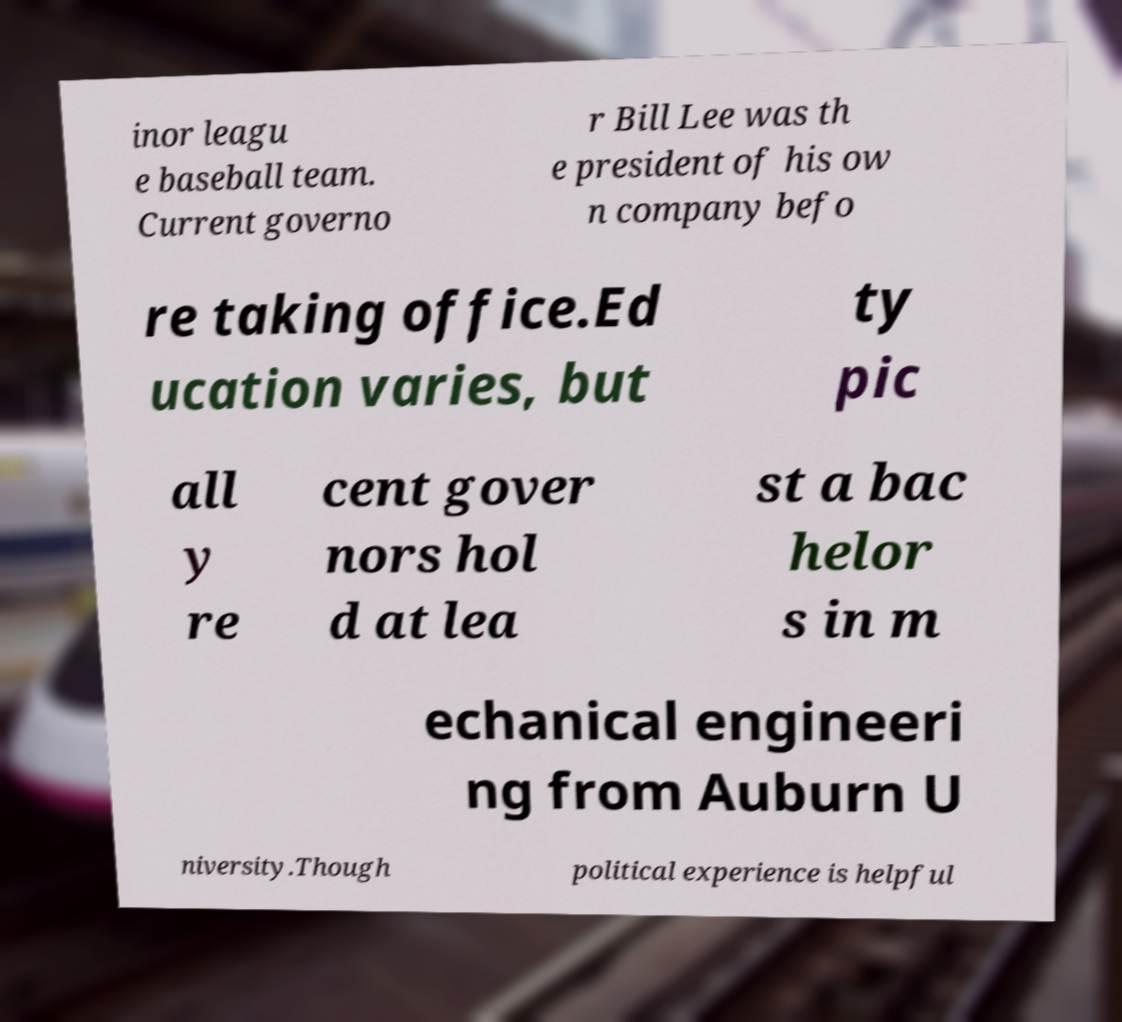Could you assist in decoding the text presented in this image and type it out clearly? inor leagu e baseball team. Current governo r Bill Lee was th e president of his ow n company befo re taking office.Ed ucation varies, but ty pic all y re cent gover nors hol d at lea st a bac helor s in m echanical engineeri ng from Auburn U niversity.Though political experience is helpful 